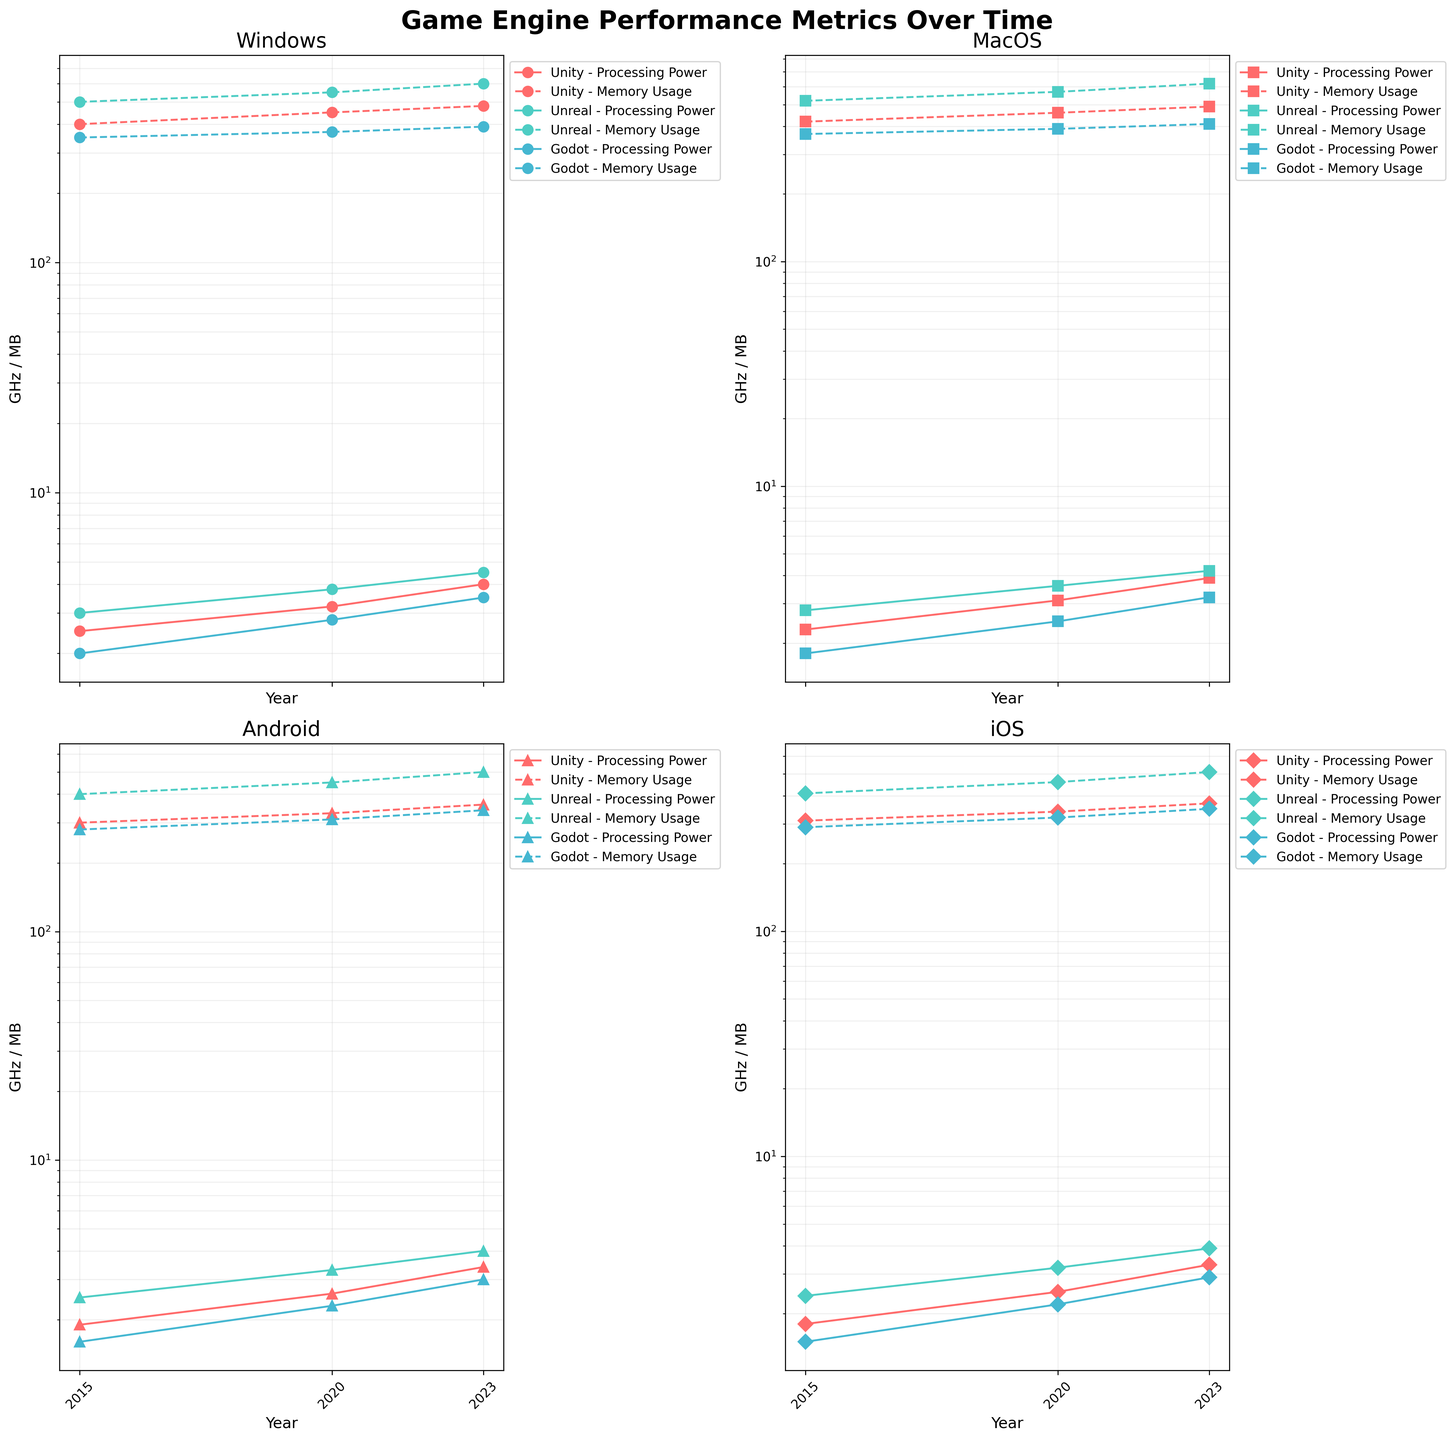What's the title of the figure? The title is usually at the top of the figure and is in bold, stating what the figure represents.
Answer: Game Engine Performance Metrics Over Time Which platform has the highest processing power for Unity in 2023? By looking at the subplot for each platform and focusing on the data points marked by Unity (with their respective colors and markers), identify the highest value for processing power in 2023.
Answer: Windows What trend do you observe in the memory usage of Unreal on MacOS between 2015 and 2023? Observe the dashed lines corresponding to Unreal on the MacOS subplot to see how memory usage changes over time. It shows a continuous increase each year from 520 MB in 2015 to 620 MB in 2023.
Answer: Increasing Comparing processing power, which game engine outperforms the others on the Android platform in 2020? Look at the Android subplot and compare the solid lines corresponding to each game engine for the year 2020. The engine with the highest value in 2020 outperforms the others. Unreal is at 3.3 GHz compared to Unity's 2.6 GHz and Godot's 2.3 GHz.
Answer: Unreal What is the percentage increase in memory usage for Godot on Windows from 2015 to 2023? First, note the memory usage for 2015 (350 MB) and for 2023 (390 MB). The percentage increase is calculated as ((390 - 350) / 350) * 100.
Answer: 11.43% Is there any platform where the processing power for Unity is the highest among all game engines in 2015? Look at the 2015 data points for processing power across all subplots for Unity and compare them with corresponding values for other engines. Unity doesn't have the highest processing power in 2015 for any platform.
Answer: No How does the processing power for different engines on iOS evolve from 2015 to 2023? Looking at the iOS subplot, observe the solid lines for each engine. Unity increases from 1.8 GHz to 3.3 GHz, Unreal from 2.4 GHz to 3.9 GHz, and Godot from 1.5 GHz to 2.9 GHz. All engines show an increasing trend.
Answer: All increasing Which game engine has the least growth in processing power on MacOS from 2015 to 2023? Calculate the difference in processing power from 2015 to 2023 for each engine on MacOS. Unity grows from 2.3 to 3.9 (1.6 GHz), Unreal from 2.8 to 4.2 (1.4 GHz), and Godot from 1.8 to 3.2 (1.4 GHz). Since Unity has the most significant increase, Godot and Unreal share the least growth with 1.4 GHz.
Answer: Godot and Unreal 